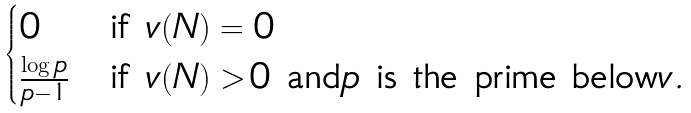Convert formula to latex. <formula><loc_0><loc_0><loc_500><loc_500>\begin{cases} 0 & \text {if ${v(N)=0}$} \\ \frac { \log p } { p - 1 } & \text {if ${v(N)>0}$ and$p$ is the prime below$v$} . \end{cases}</formula> 